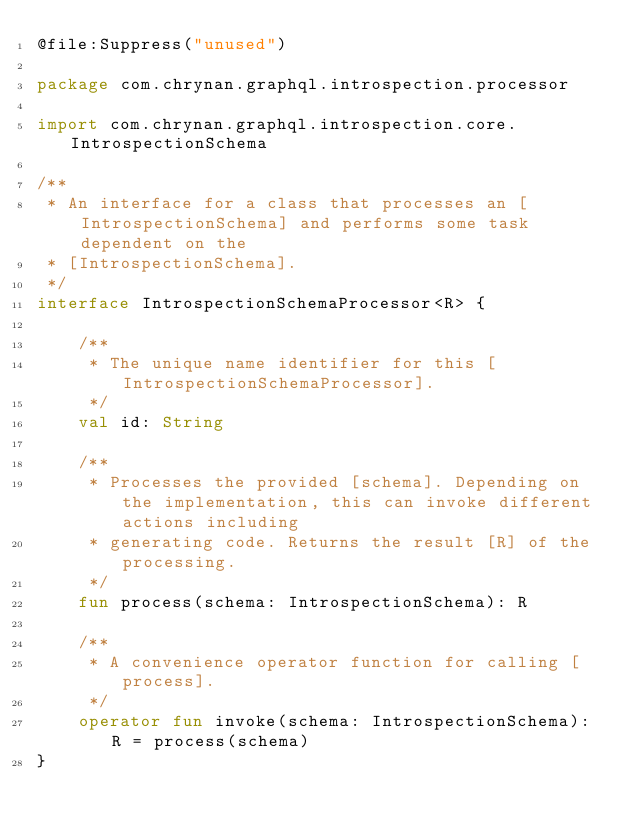<code> <loc_0><loc_0><loc_500><loc_500><_Kotlin_>@file:Suppress("unused")

package com.chrynan.graphql.introspection.processor

import com.chrynan.graphql.introspection.core.IntrospectionSchema

/**
 * An interface for a class that processes an [IntrospectionSchema] and performs some task dependent on the
 * [IntrospectionSchema].
 */
interface IntrospectionSchemaProcessor<R> {

    /**
     * The unique name identifier for this [IntrospectionSchemaProcessor].
     */
    val id: String

    /**
     * Processes the provided [schema]. Depending on the implementation, this can invoke different actions including
     * generating code. Returns the result [R] of the processing.
     */
    fun process(schema: IntrospectionSchema): R

    /**
     * A convenience operator function for calling [process].
     */
    operator fun invoke(schema: IntrospectionSchema): R = process(schema)
}
</code> 